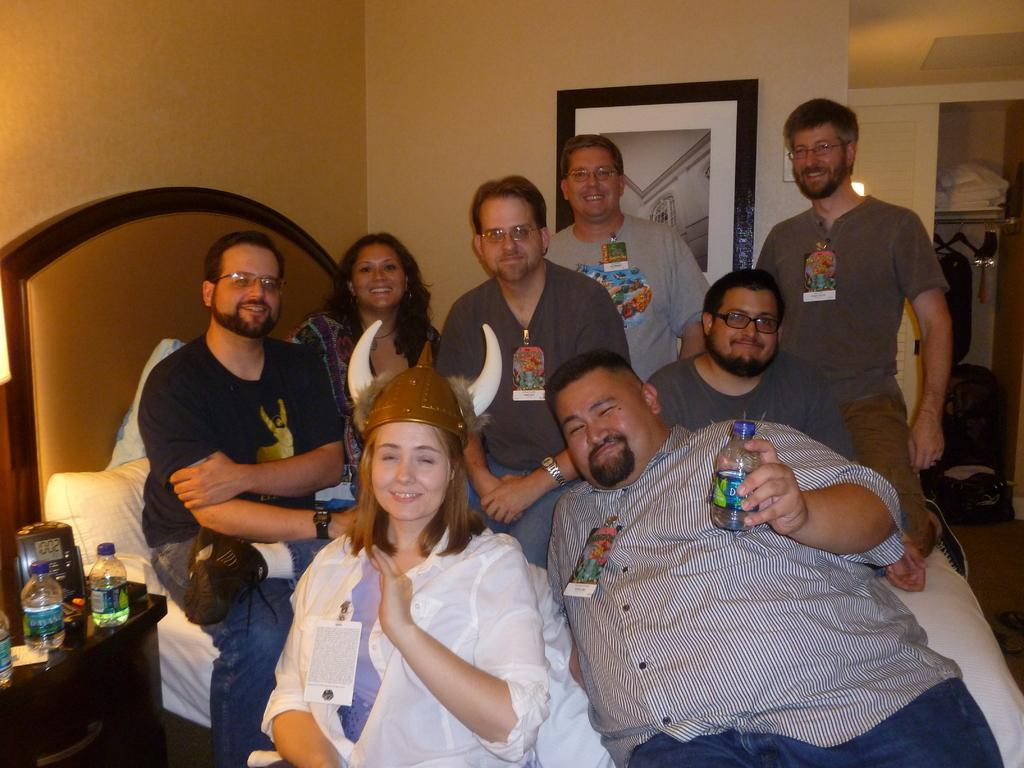What is happening with the group of people in the image? The people in the image are smoking. What can be found in the room where the people are? There is a bed with pillows, bottles, and a frame on the wall. What is visible in the background of the image? Clothes are visible in the background of the image. Are there any fairies flying around the people in the image? No, there are no fairies present in the image. What type of cent is visible in the image? There is no cent present in the image. 